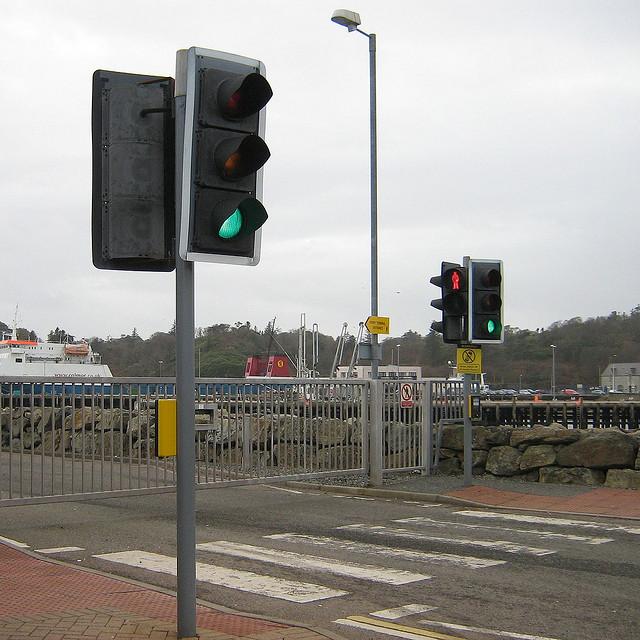Is this a crosswalk?
Write a very short answer. Yes. Are there any cars?
Write a very short answer. No. What kind of road is this?
Answer briefly. Paved. 